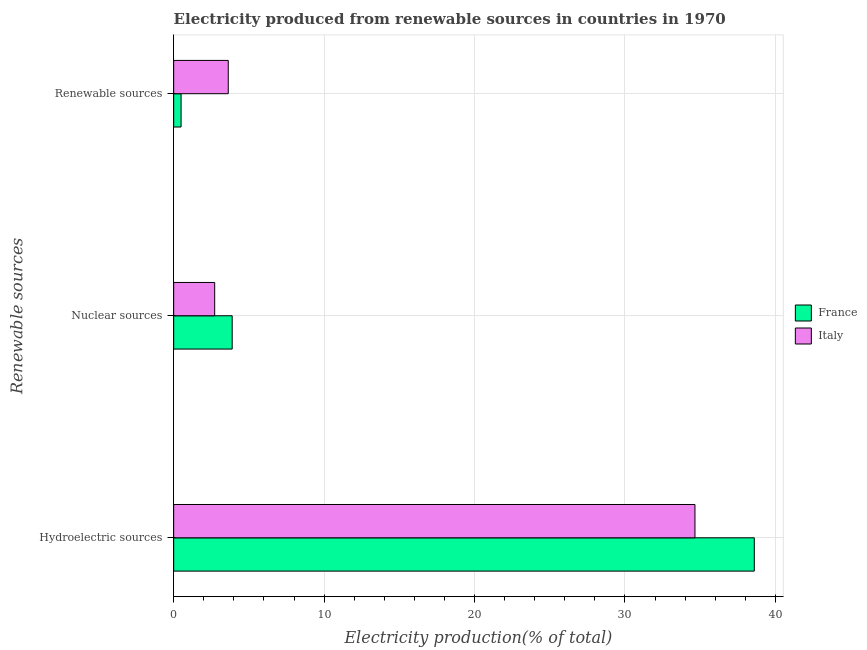How many groups of bars are there?
Ensure brevity in your answer.  3. Are the number of bars per tick equal to the number of legend labels?
Your answer should be compact. Yes. How many bars are there on the 3rd tick from the bottom?
Ensure brevity in your answer.  2. What is the label of the 3rd group of bars from the top?
Your answer should be very brief. Hydroelectric sources. What is the percentage of electricity produced by hydroelectric sources in France?
Your answer should be very brief. 38.6. Across all countries, what is the maximum percentage of electricity produced by renewable sources?
Ensure brevity in your answer.  3.63. Across all countries, what is the minimum percentage of electricity produced by hydroelectric sources?
Your response must be concise. 34.66. In which country was the percentage of electricity produced by hydroelectric sources minimum?
Offer a very short reply. Italy. What is the total percentage of electricity produced by nuclear sources in the graph?
Provide a succinct answer. 6.62. What is the difference between the percentage of electricity produced by nuclear sources in France and that in Italy?
Offer a very short reply. 1.16. What is the difference between the percentage of electricity produced by hydroelectric sources in Italy and the percentage of electricity produced by nuclear sources in France?
Ensure brevity in your answer.  30.77. What is the average percentage of electricity produced by hydroelectric sources per country?
Offer a terse response. 36.63. What is the difference between the percentage of electricity produced by renewable sources and percentage of electricity produced by nuclear sources in Italy?
Your answer should be very brief. 0.9. What is the ratio of the percentage of electricity produced by renewable sources in France to that in Italy?
Your answer should be very brief. 0.14. Is the percentage of electricity produced by nuclear sources in Italy less than that in France?
Your answer should be compact. Yes. What is the difference between the highest and the second highest percentage of electricity produced by hydroelectric sources?
Give a very brief answer. 3.94. What is the difference between the highest and the lowest percentage of electricity produced by nuclear sources?
Provide a short and direct response. 1.16. Is the sum of the percentage of electricity produced by nuclear sources in France and Italy greater than the maximum percentage of electricity produced by hydroelectric sources across all countries?
Provide a succinct answer. No. What does the 2nd bar from the top in Hydroelectric sources represents?
Your response must be concise. France. What does the 1st bar from the bottom in Nuclear sources represents?
Provide a succinct answer. France. Is it the case that in every country, the sum of the percentage of electricity produced by hydroelectric sources and percentage of electricity produced by nuclear sources is greater than the percentage of electricity produced by renewable sources?
Ensure brevity in your answer.  Yes. How many bars are there?
Offer a terse response. 6. Are all the bars in the graph horizontal?
Provide a short and direct response. Yes. Are the values on the major ticks of X-axis written in scientific E-notation?
Your answer should be very brief. No. Does the graph contain any zero values?
Make the answer very short. No. Does the graph contain grids?
Your response must be concise. Yes. How many legend labels are there?
Provide a short and direct response. 2. How are the legend labels stacked?
Offer a terse response. Vertical. What is the title of the graph?
Your response must be concise. Electricity produced from renewable sources in countries in 1970. Does "Middle East & North Africa (developing only)" appear as one of the legend labels in the graph?
Offer a terse response. No. What is the label or title of the Y-axis?
Offer a very short reply. Renewable sources. What is the Electricity production(% of total) of France in Hydroelectric sources?
Make the answer very short. 38.6. What is the Electricity production(% of total) of Italy in Hydroelectric sources?
Keep it short and to the point. 34.66. What is the Electricity production(% of total) in France in Nuclear sources?
Provide a succinct answer. 3.89. What is the Electricity production(% of total) in Italy in Nuclear sources?
Give a very brief answer. 2.73. What is the Electricity production(% of total) of France in Renewable sources?
Provide a short and direct response. 0.49. What is the Electricity production(% of total) in Italy in Renewable sources?
Make the answer very short. 3.63. Across all Renewable sources, what is the maximum Electricity production(% of total) of France?
Offer a very short reply. 38.6. Across all Renewable sources, what is the maximum Electricity production(% of total) of Italy?
Give a very brief answer. 34.66. Across all Renewable sources, what is the minimum Electricity production(% of total) in France?
Give a very brief answer. 0.49. Across all Renewable sources, what is the minimum Electricity production(% of total) in Italy?
Provide a succinct answer. 2.73. What is the total Electricity production(% of total) of France in the graph?
Offer a terse response. 42.98. What is the total Electricity production(% of total) of Italy in the graph?
Offer a very short reply. 41.01. What is the difference between the Electricity production(% of total) in France in Hydroelectric sources and that in Nuclear sources?
Keep it short and to the point. 34.71. What is the difference between the Electricity production(% of total) of Italy in Hydroelectric sources and that in Nuclear sources?
Keep it short and to the point. 31.93. What is the difference between the Electricity production(% of total) in France in Hydroelectric sources and that in Renewable sources?
Your answer should be very brief. 38.11. What is the difference between the Electricity production(% of total) in Italy in Hydroelectric sources and that in Renewable sources?
Make the answer very short. 31.03. What is the difference between the Electricity production(% of total) of France in Nuclear sources and that in Renewable sources?
Offer a terse response. 3.4. What is the difference between the Electricity production(% of total) of Italy in Nuclear sources and that in Renewable sources?
Your answer should be compact. -0.9. What is the difference between the Electricity production(% of total) in France in Hydroelectric sources and the Electricity production(% of total) in Italy in Nuclear sources?
Your answer should be very brief. 35.87. What is the difference between the Electricity production(% of total) of France in Hydroelectric sources and the Electricity production(% of total) of Italy in Renewable sources?
Ensure brevity in your answer.  34.97. What is the difference between the Electricity production(% of total) in France in Nuclear sources and the Electricity production(% of total) in Italy in Renewable sources?
Ensure brevity in your answer.  0.26. What is the average Electricity production(% of total) of France per Renewable sources?
Your answer should be very brief. 14.33. What is the average Electricity production(% of total) in Italy per Renewable sources?
Your answer should be very brief. 13.67. What is the difference between the Electricity production(% of total) of France and Electricity production(% of total) of Italy in Hydroelectric sources?
Offer a terse response. 3.94. What is the difference between the Electricity production(% of total) in France and Electricity production(% of total) in Italy in Nuclear sources?
Give a very brief answer. 1.16. What is the difference between the Electricity production(% of total) in France and Electricity production(% of total) in Italy in Renewable sources?
Your answer should be compact. -3.14. What is the ratio of the Electricity production(% of total) of France in Hydroelectric sources to that in Nuclear sources?
Your answer should be compact. 9.92. What is the ratio of the Electricity production(% of total) of Italy in Hydroelectric sources to that in Nuclear sources?
Your answer should be very brief. 12.71. What is the ratio of the Electricity production(% of total) of France in Hydroelectric sources to that in Renewable sources?
Offer a very short reply. 78.39. What is the ratio of the Electricity production(% of total) in Italy in Hydroelectric sources to that in Renewable sources?
Ensure brevity in your answer.  9.55. What is the ratio of the Electricity production(% of total) of France in Nuclear sources to that in Renewable sources?
Keep it short and to the point. 7.9. What is the ratio of the Electricity production(% of total) in Italy in Nuclear sources to that in Renewable sources?
Your response must be concise. 0.75. What is the difference between the highest and the second highest Electricity production(% of total) in France?
Provide a succinct answer. 34.71. What is the difference between the highest and the second highest Electricity production(% of total) of Italy?
Your answer should be compact. 31.03. What is the difference between the highest and the lowest Electricity production(% of total) in France?
Offer a terse response. 38.11. What is the difference between the highest and the lowest Electricity production(% of total) of Italy?
Provide a succinct answer. 31.93. 